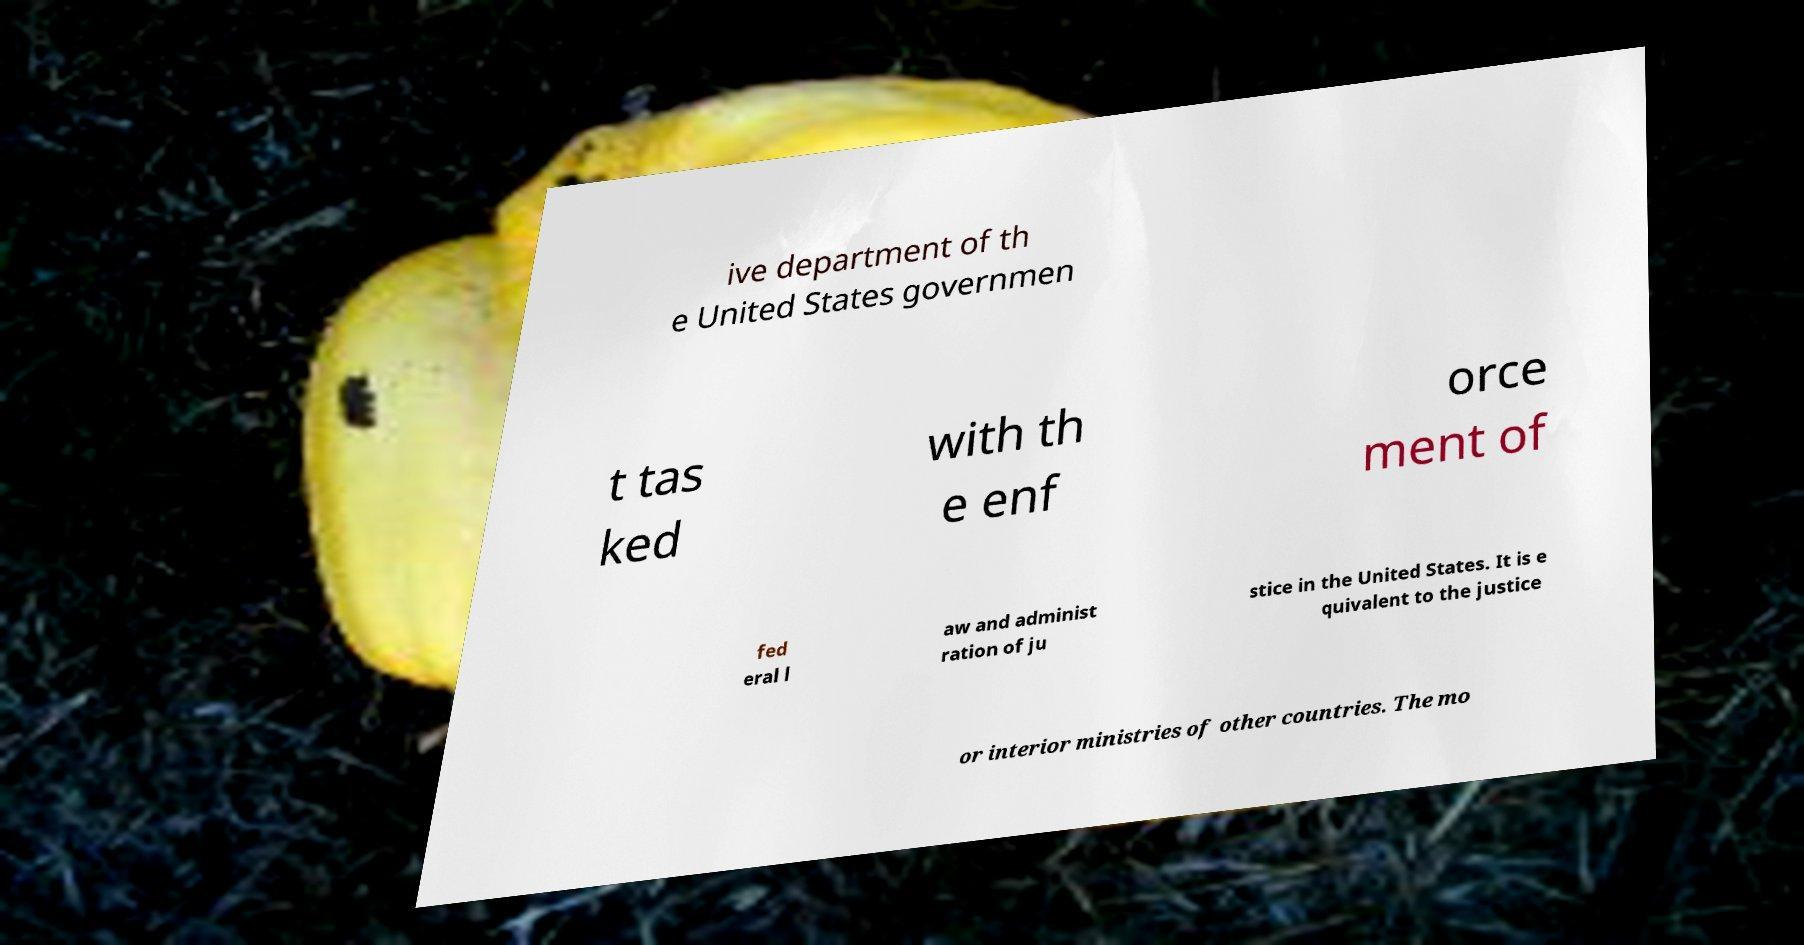Can you read and provide the text displayed in the image?This photo seems to have some interesting text. Can you extract and type it out for me? ive department of th e United States governmen t tas ked with th e enf orce ment of fed eral l aw and administ ration of ju stice in the United States. It is e quivalent to the justice or interior ministries of other countries. The mo 